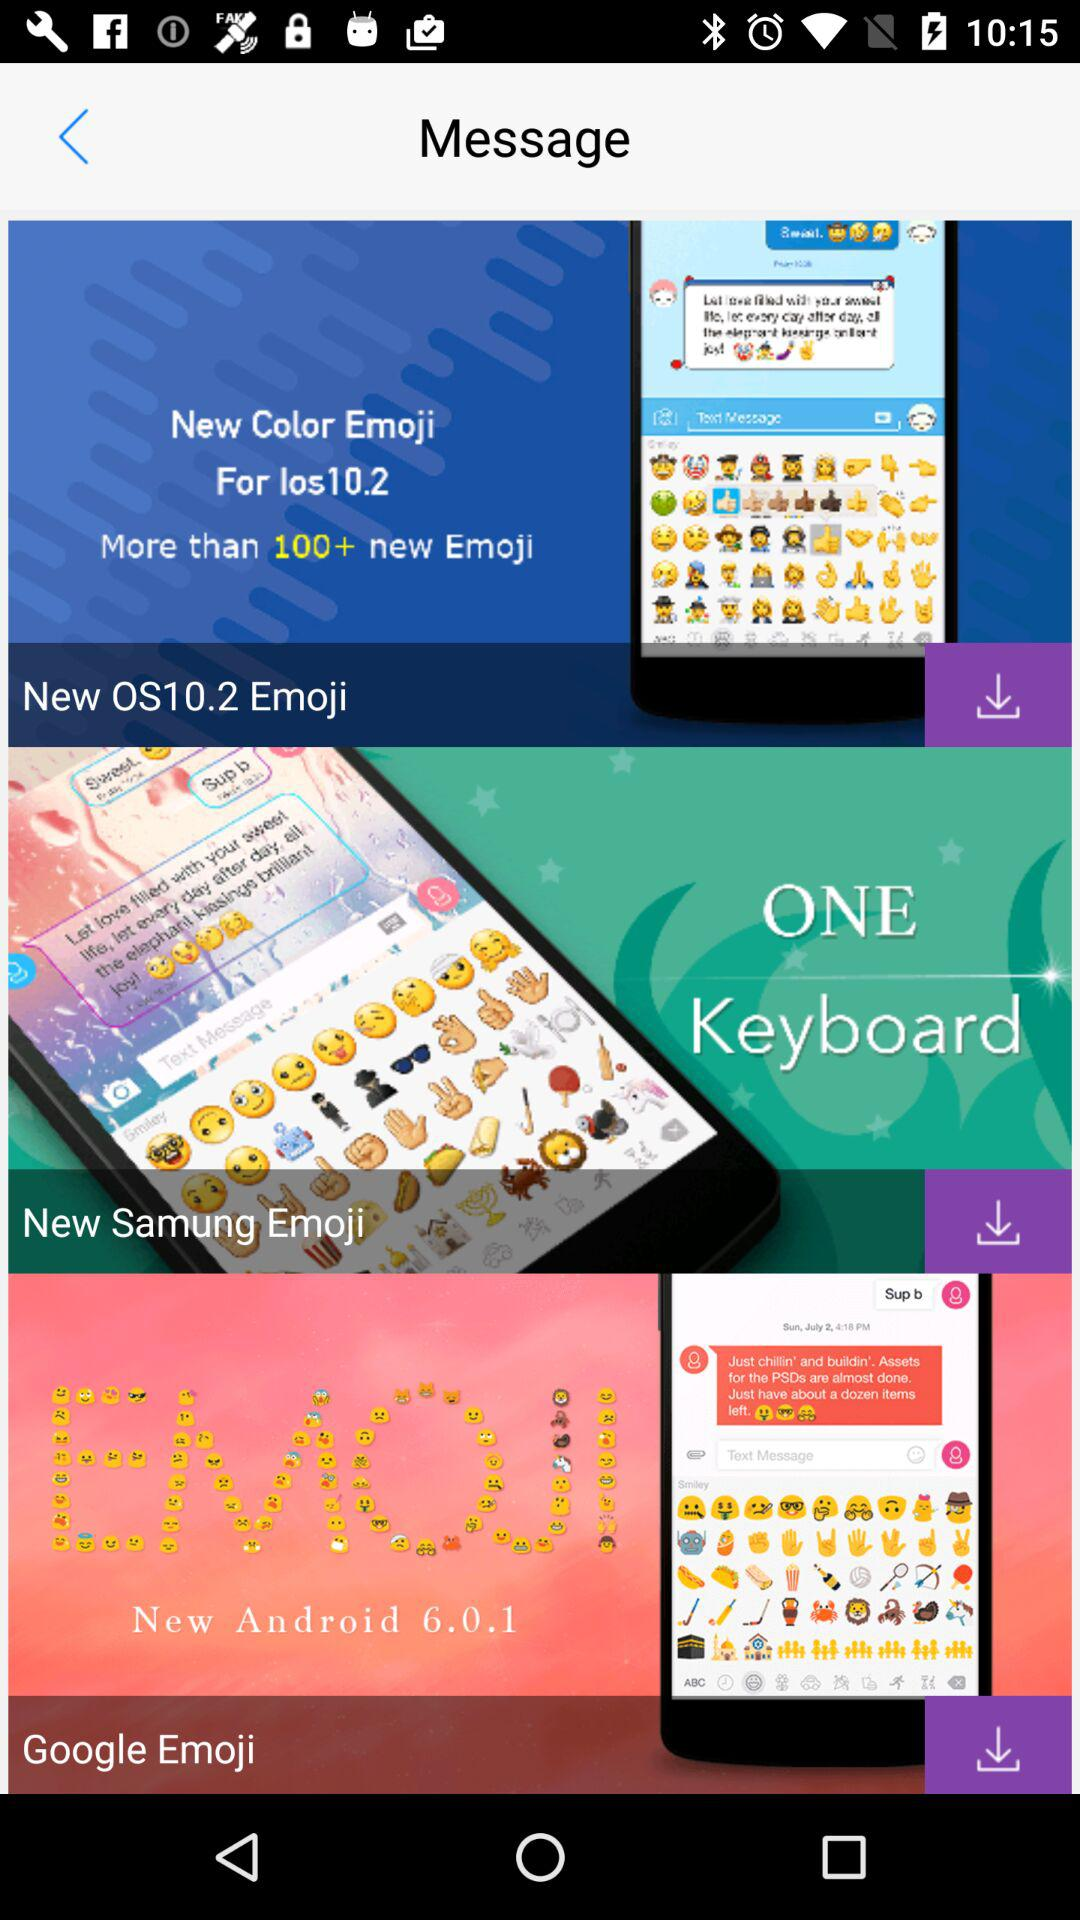What is the count of new emoji? The count of new emoji is more than 100. 